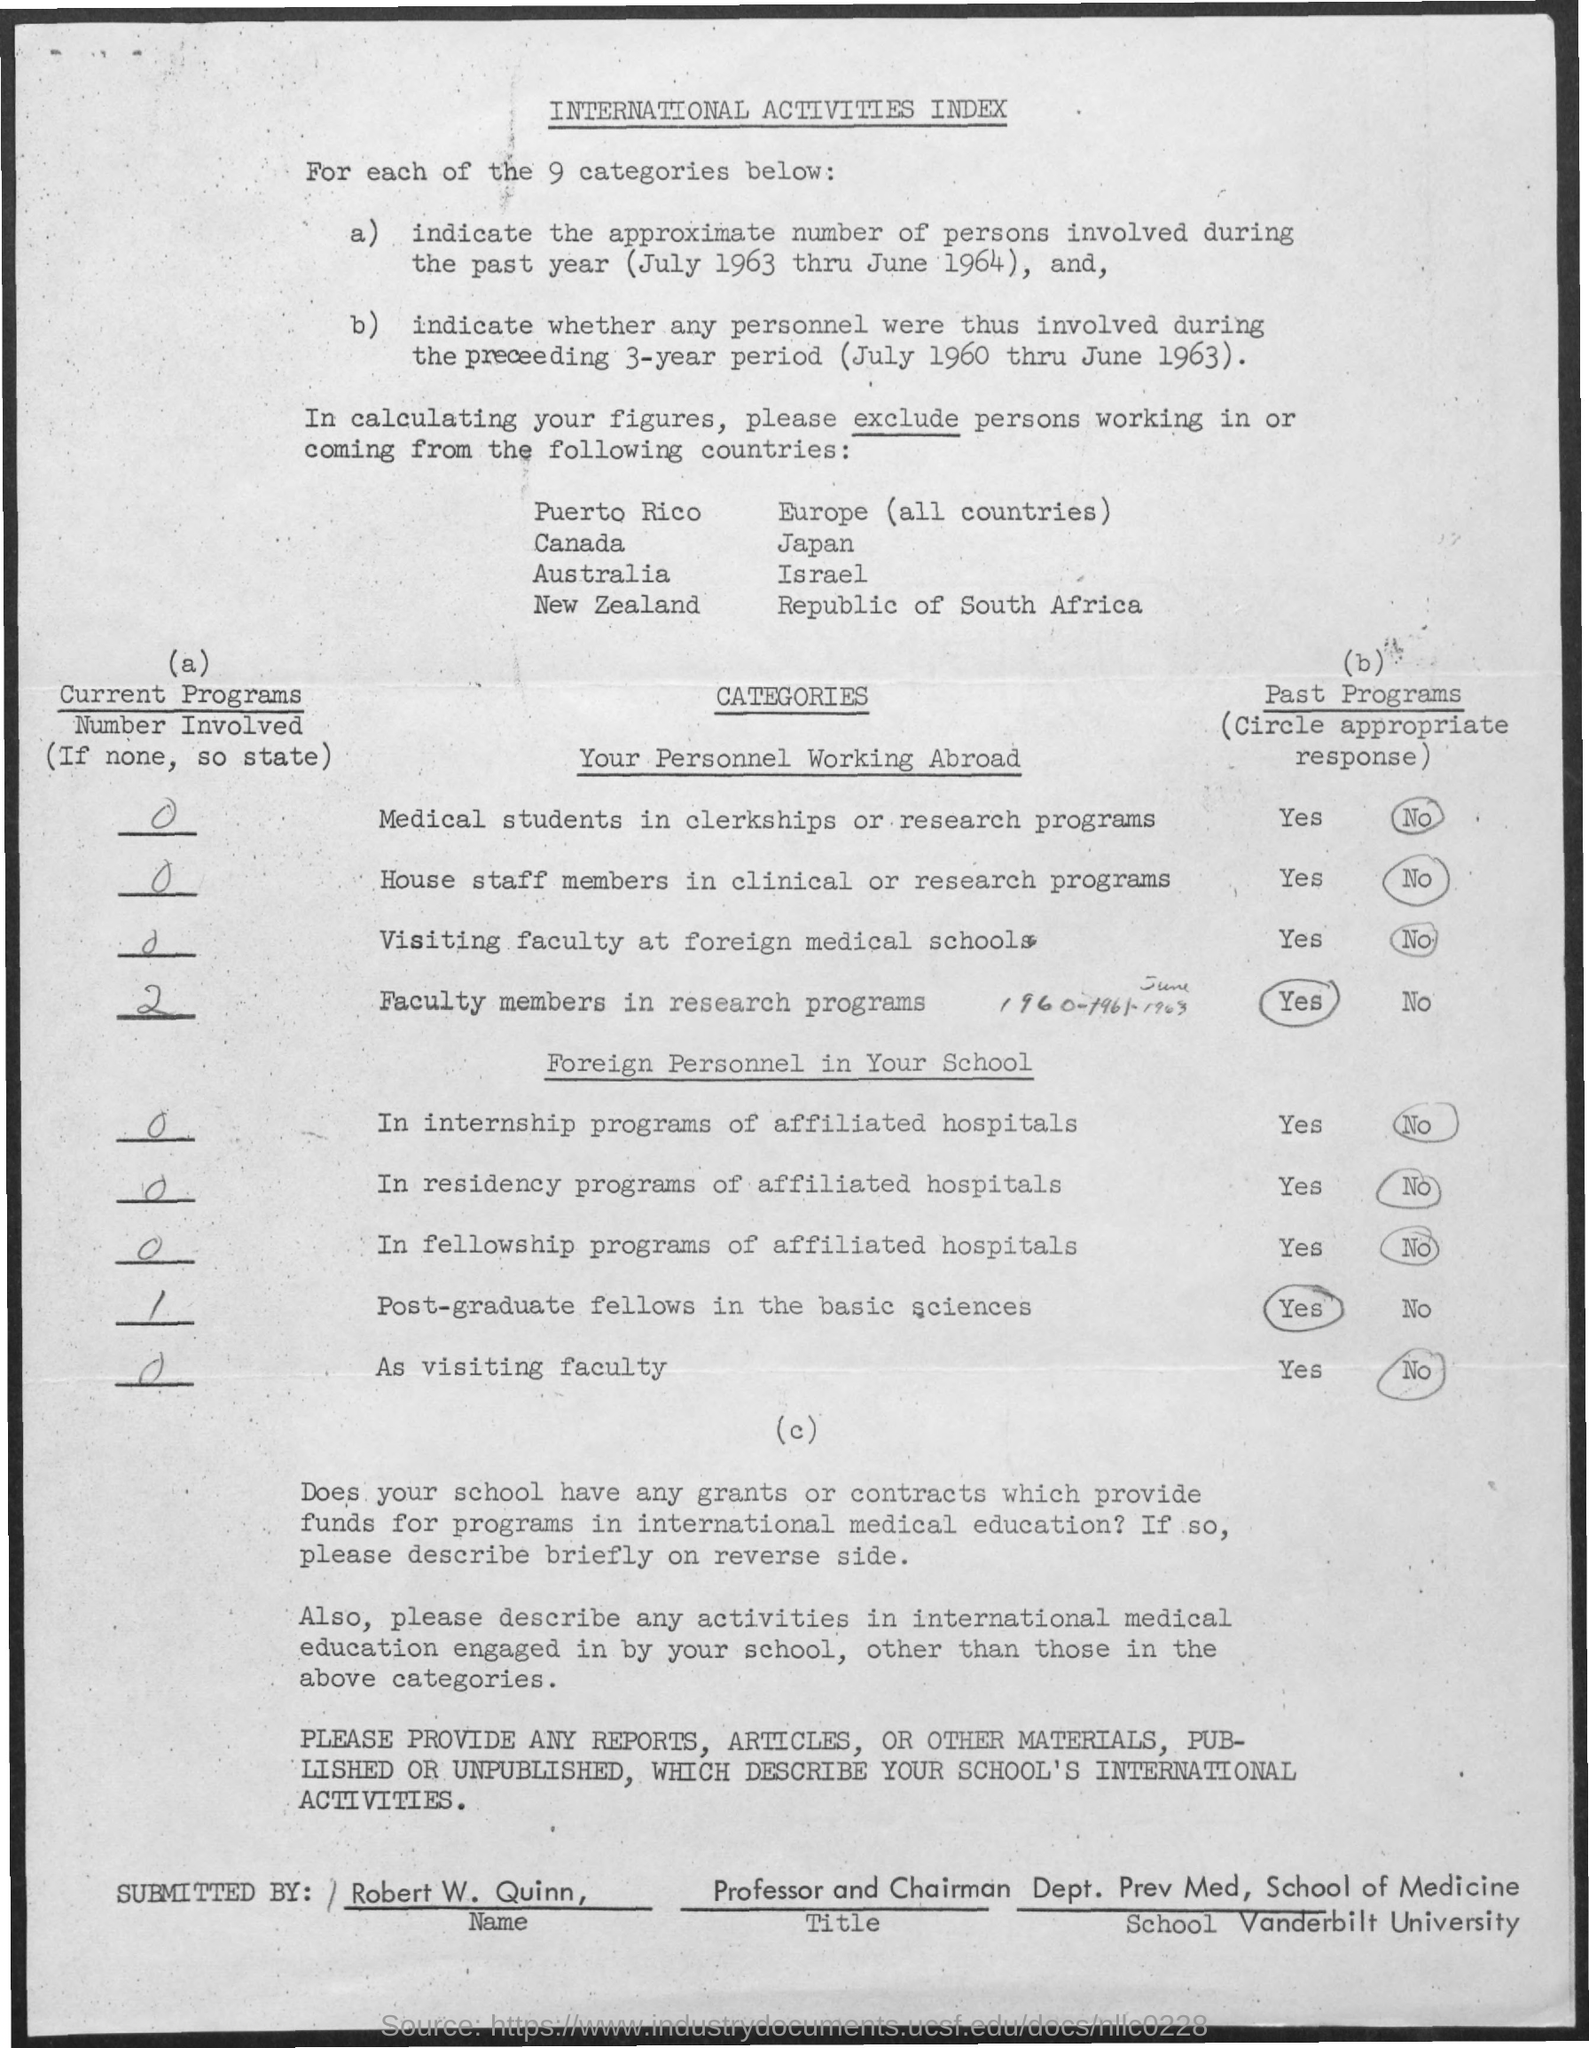Highlight a few significant elements in this photo. There are nine categories. Robert W. Quinn holds the designation of professor and chairman. The title of the document is 'International Activities Index.' Robert W. Quinn is a member of Vanderbilt University. 